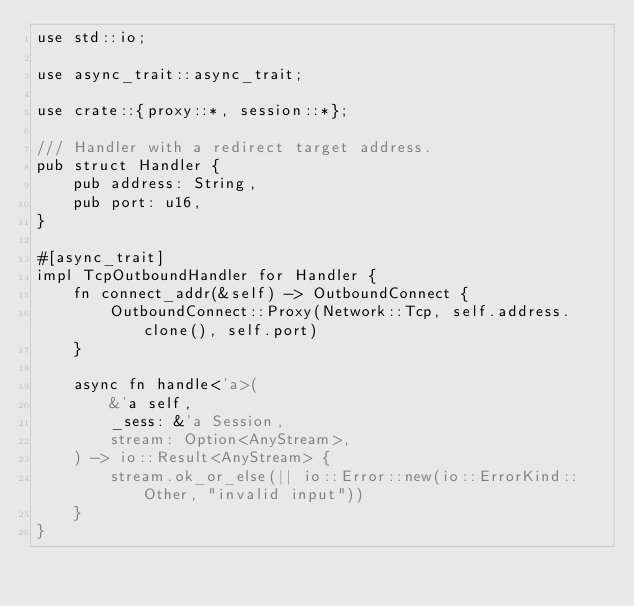<code> <loc_0><loc_0><loc_500><loc_500><_Rust_>use std::io;

use async_trait::async_trait;

use crate::{proxy::*, session::*};

/// Handler with a redirect target address.
pub struct Handler {
    pub address: String,
    pub port: u16,
}

#[async_trait]
impl TcpOutboundHandler for Handler {
    fn connect_addr(&self) -> OutboundConnect {
        OutboundConnect::Proxy(Network::Tcp, self.address.clone(), self.port)
    }

    async fn handle<'a>(
        &'a self,
        _sess: &'a Session,
        stream: Option<AnyStream>,
    ) -> io::Result<AnyStream> {
        stream.ok_or_else(|| io::Error::new(io::ErrorKind::Other, "invalid input"))
    }
}
</code> 